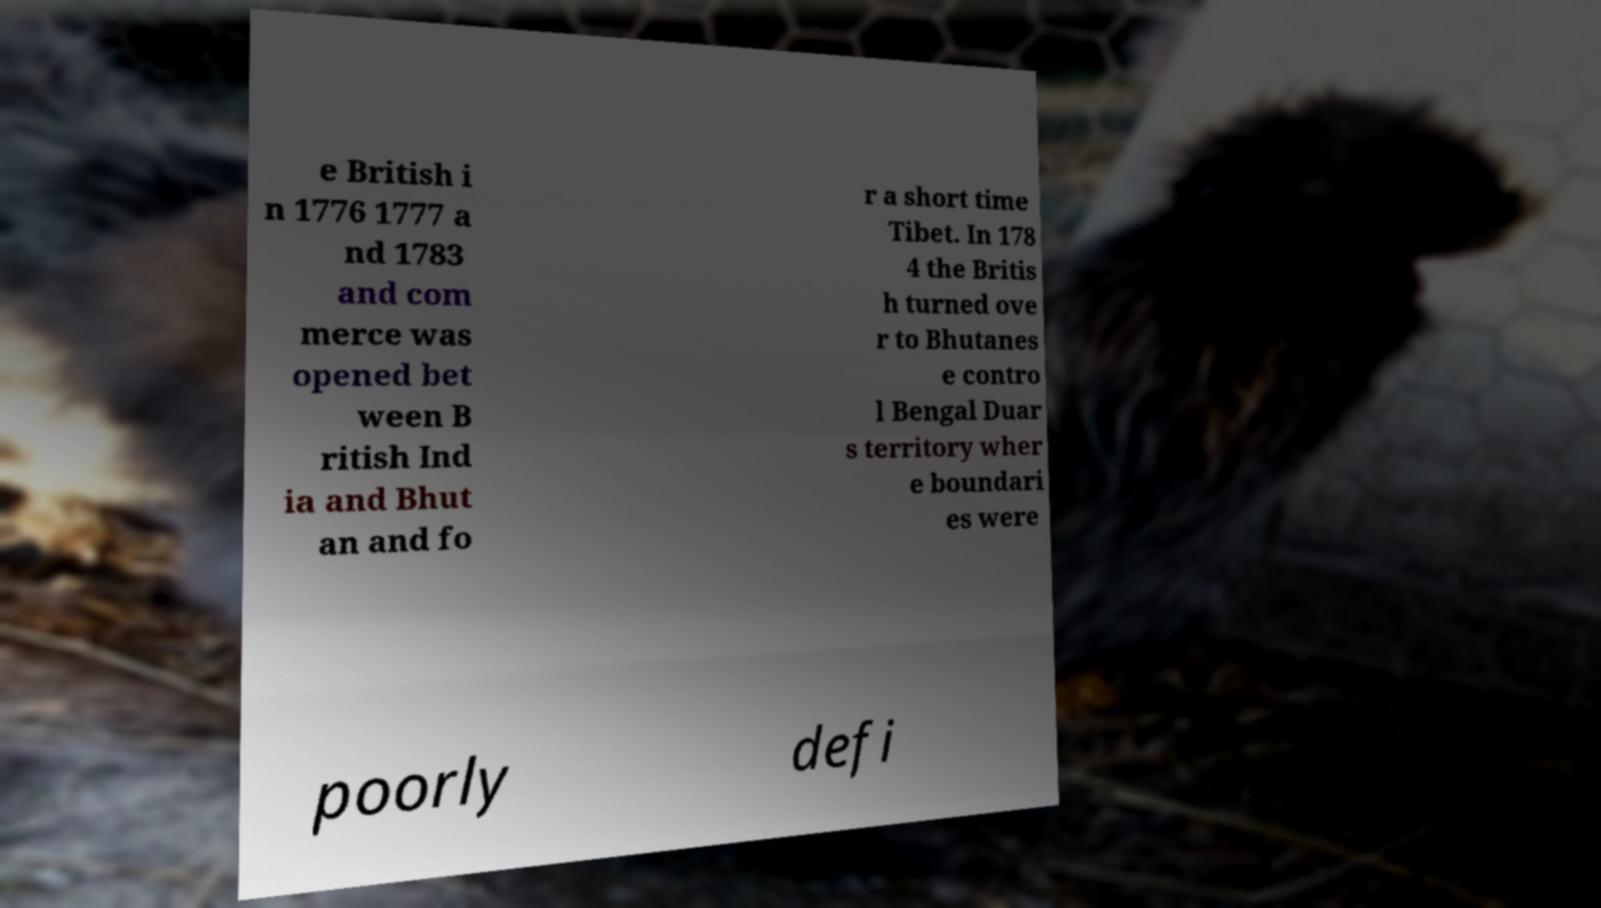For documentation purposes, I need the text within this image transcribed. Could you provide that? e British i n 1776 1777 a nd 1783 and com merce was opened bet ween B ritish Ind ia and Bhut an and fo r a short time Tibet. In 178 4 the Britis h turned ove r to Bhutanes e contro l Bengal Duar s territory wher e boundari es were poorly defi 